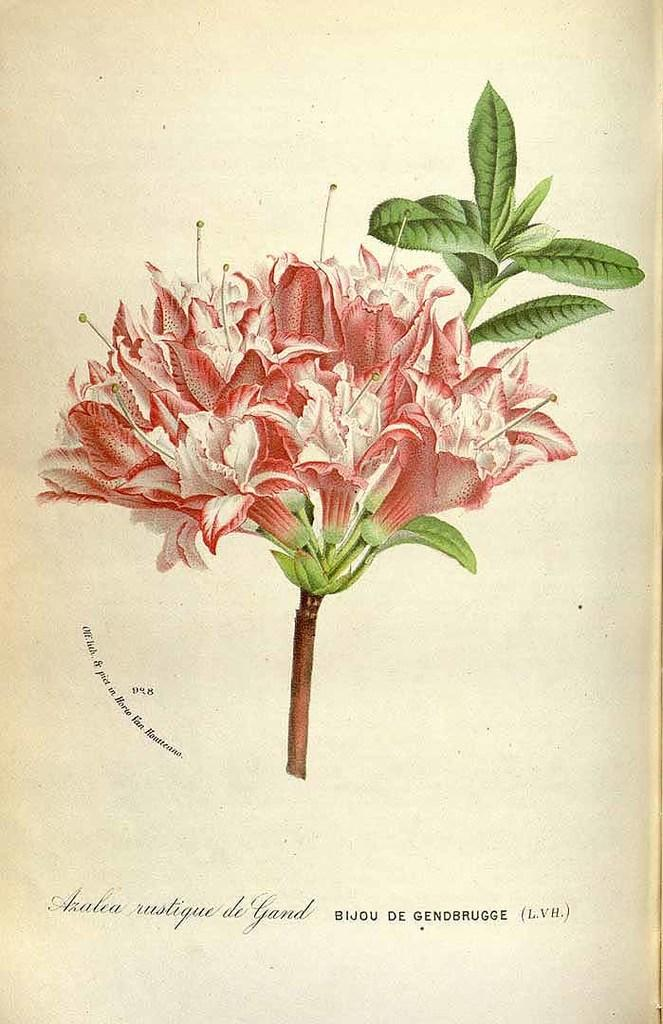What is the main subject of the image? There is a flower in the image. Where is the flower placed? The flower is on a paper. What colors can be seen on the flower? The flower has pink and white colors. Are there any leaves associated with the flower? Yes, there are green leaves associated with the flower. What is the income of the flower in the image? There is no concept of income for a flower, as it is a living organism and not a person or entity that generates income. 